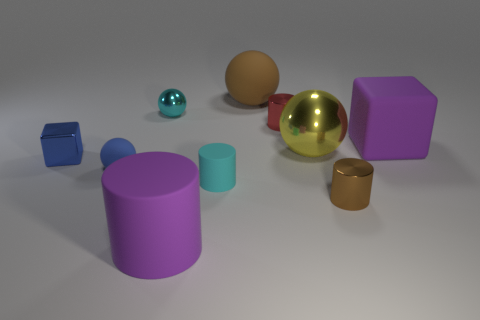Subtract all cylinders. How many objects are left? 6 Subtract 1 yellow spheres. How many objects are left? 9 Subtract all small cyan matte things. Subtract all large metal balls. How many objects are left? 8 Add 5 small brown things. How many small brown things are left? 6 Add 8 tiny yellow things. How many tiny yellow things exist? 8 